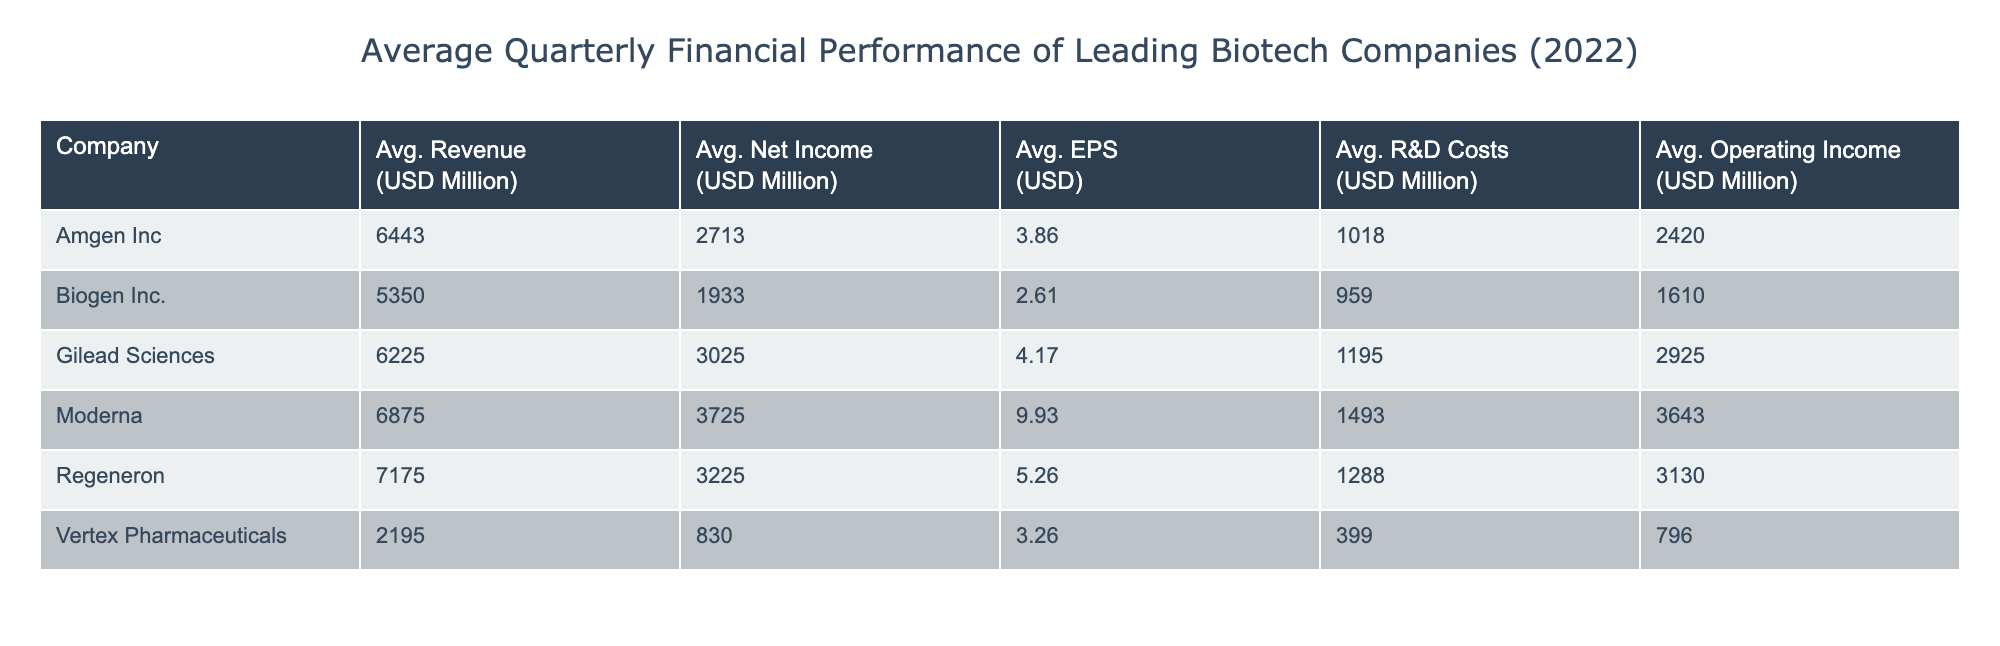What was the average net income for Gilead Sciences in 2022? To find the average net income for Gilead Sciences, we need to sum the net income values from each quarter: 3000 + 2950 + 3100 + 3050 = 12100. Then, we divide by 4 (the number of quarters), which gives us 12100 / 4 = 3025.
Answer: 3025 Which company had the highest average revenue in 2022? To determine the company with the highest average revenue, we compare the average revenues of all companies. The average revenues calculated are: Amgen Inc (6420), Gilead Sciences (6175), Biogen Inc. (5225), Regeneron (7335), Vertex Pharmaceuticals (2200), and Moderna (6825). Regeneron has the highest average of 7335.
Answer: Regeneron Did Vertex Pharmaceuticals have a higher average earnings per share than Biogen Inc.? The average earnings per share for Vertex Pharmaceuticals is calculated as: (3.20 + 3.15 + 3.38 + 3.33) / 4 = 3.26. For Biogen Inc., it is (2.56 + 2.50 + 2.70 + 2.67) / 4 = 2.61. Since 3.26 > 2.61, Vertex Pharmaceuticals did have a higher average EPS.
Answer: Yes What is the total R&D costs incurred by Amgen Inc. over the four quarters? To find the total R&D costs for Amgen Inc., we sum the R&D costs from each quarter: 1000 + 1040 + 1020 + 1010 = 4070. Thus, the total R&D costs are 4070.
Answer: 4070 Calculate the average operating income for all companies in 2022. The operating incomes for each company across the four quarters are: Amgen Inc (2400 + 2350 + 2480 + 2450 = 9680), Gilead Sciences (2900 + 2850 + 3000 + 2950 = 11750), Biogen Inc. (1600 + 1570 + 1650 + 1620 = 6440), Regeneron (3100 + 3050 + 3200 + 3170 = 12520), Vertex Pharmaceuticals (780 + 765 + 825 + 815 = 3185), and Moderna (3600 + 3550 + 3720 + 3700 = 14570). Adding these gives us 9680 + 11750 + 6440 + 12520 + 3185 + 14570 = 57325. We divide by 6 (the number of companies) to find the average: 57325 / 6 = 9554.17.
Answer: 9554.17 Is it true that Moderna had a higher average net income than Amgen Inc. in 2022? The average net income for Moderna is calculated as: (3700 + 3650 + 3800 + 3750) / 4 = 3725. For Amgen Inc., it is (2700 + 2620 + 2780 + 2750) / 4 = 2712.5. Since 3725 > 2712.5, it is true that Moderna had a higher average net income.
Answer: Yes 